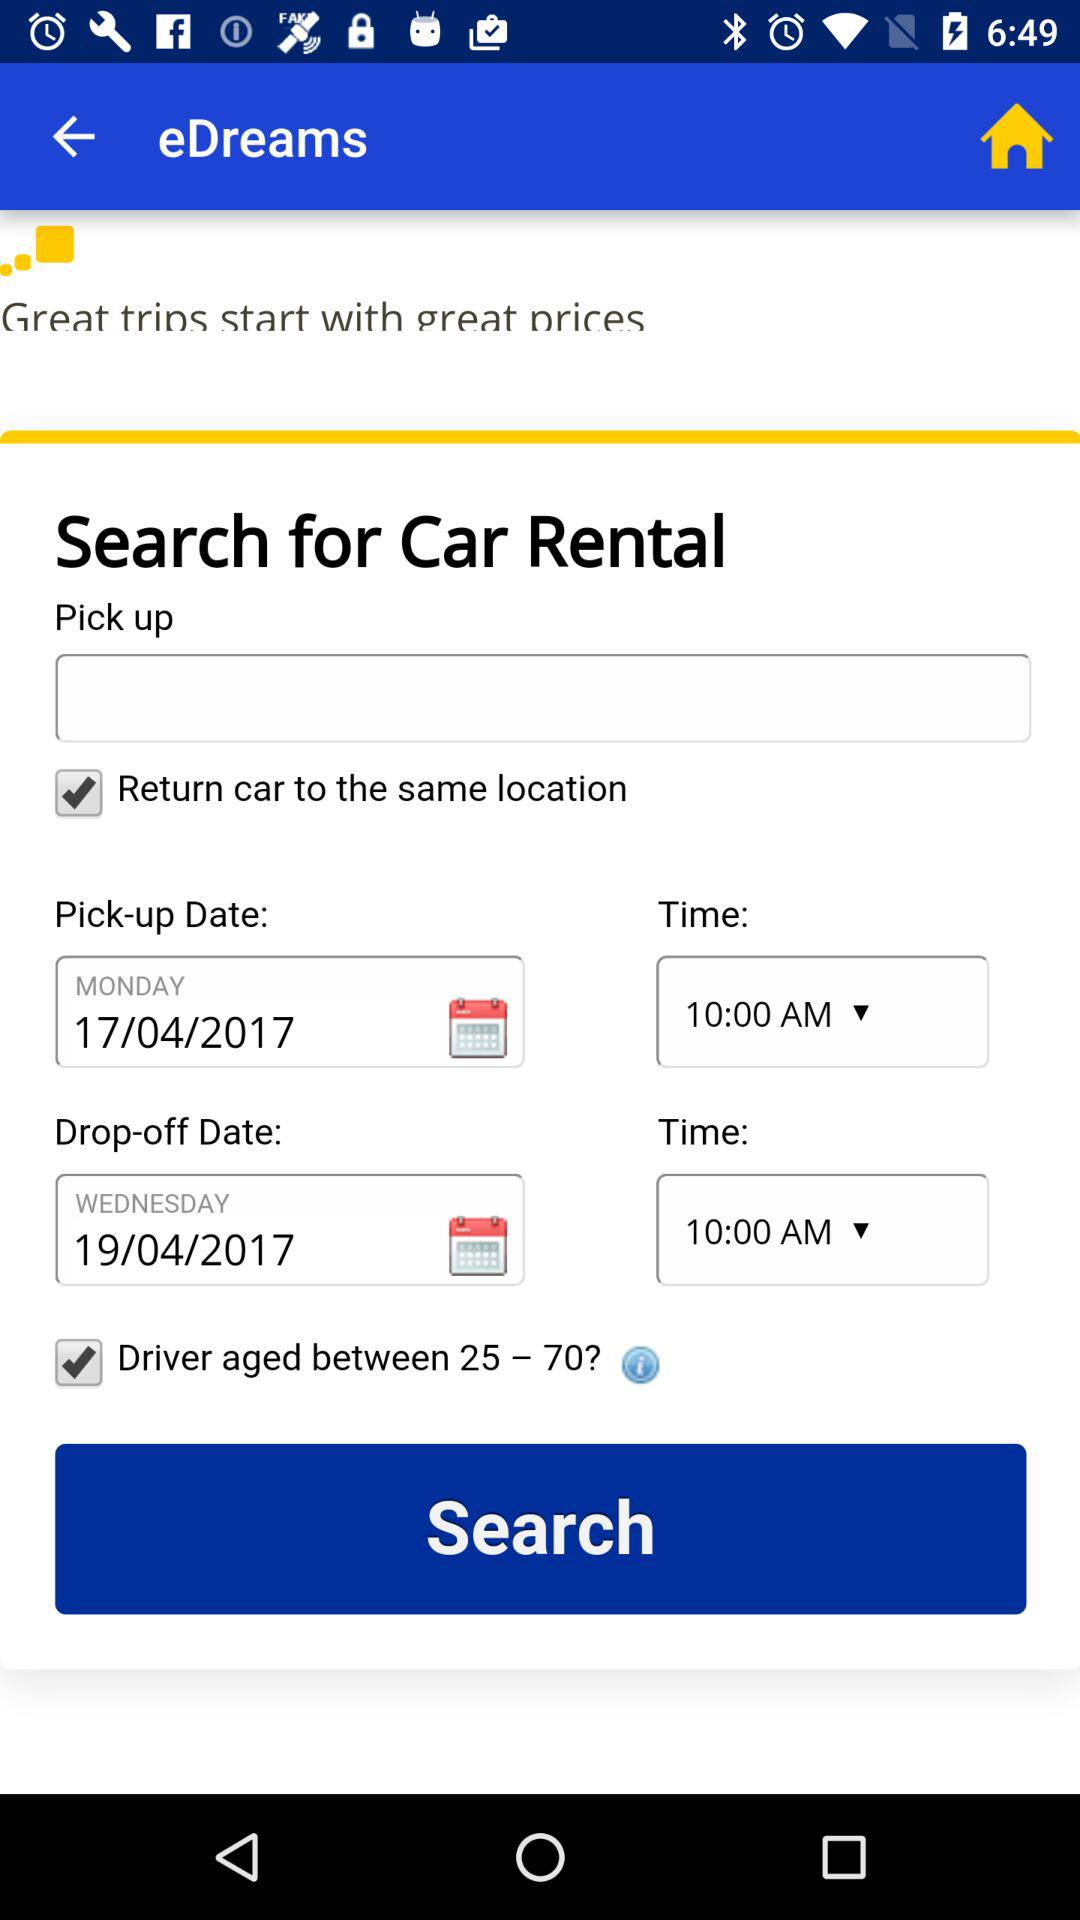What is the pick-up date and time? The pick-up date and time are Monday, April 17, 2017 and 10:00 AM, respectively. 